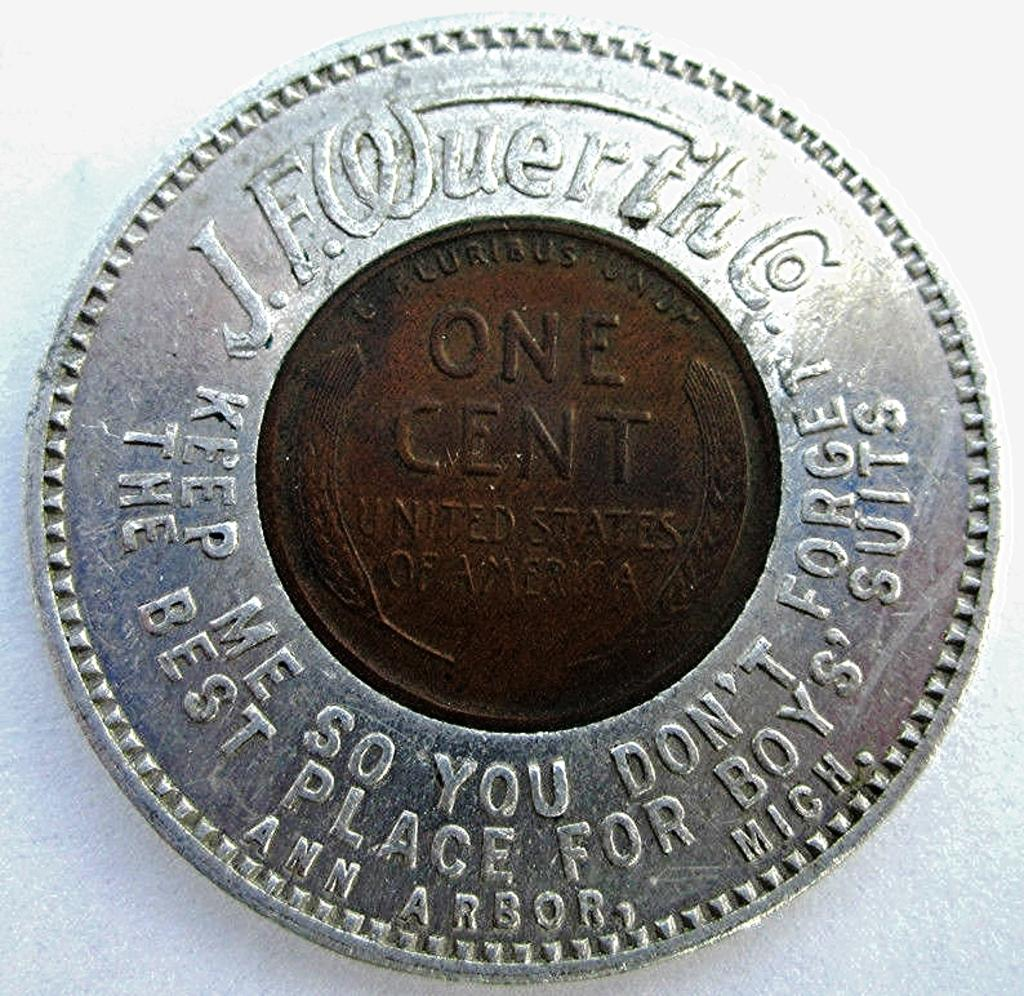Provide a one-sentence caption for the provided image. An old one cent coin made in Ann Arbor, Mich, United States. 